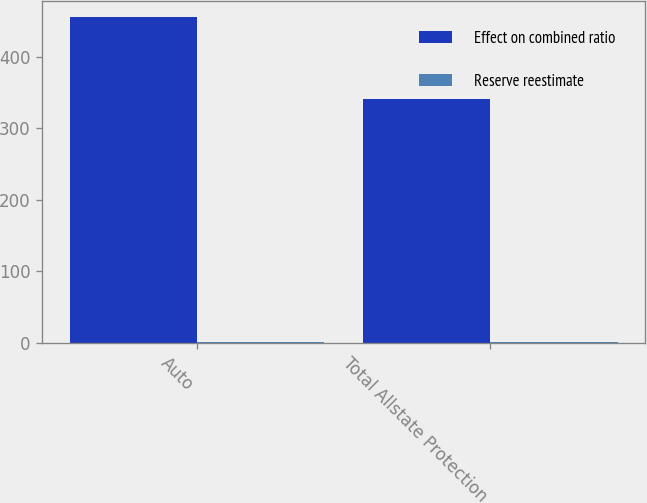Convert chart to OTSL. <chart><loc_0><loc_0><loc_500><loc_500><stacked_bar_chart><ecel><fcel>Auto<fcel>Total Allstate Protection<nl><fcel>Effect on combined ratio<fcel>455<fcel>340<nl><fcel>Reserve reestimate<fcel>1.3<fcel>1<nl></chart> 